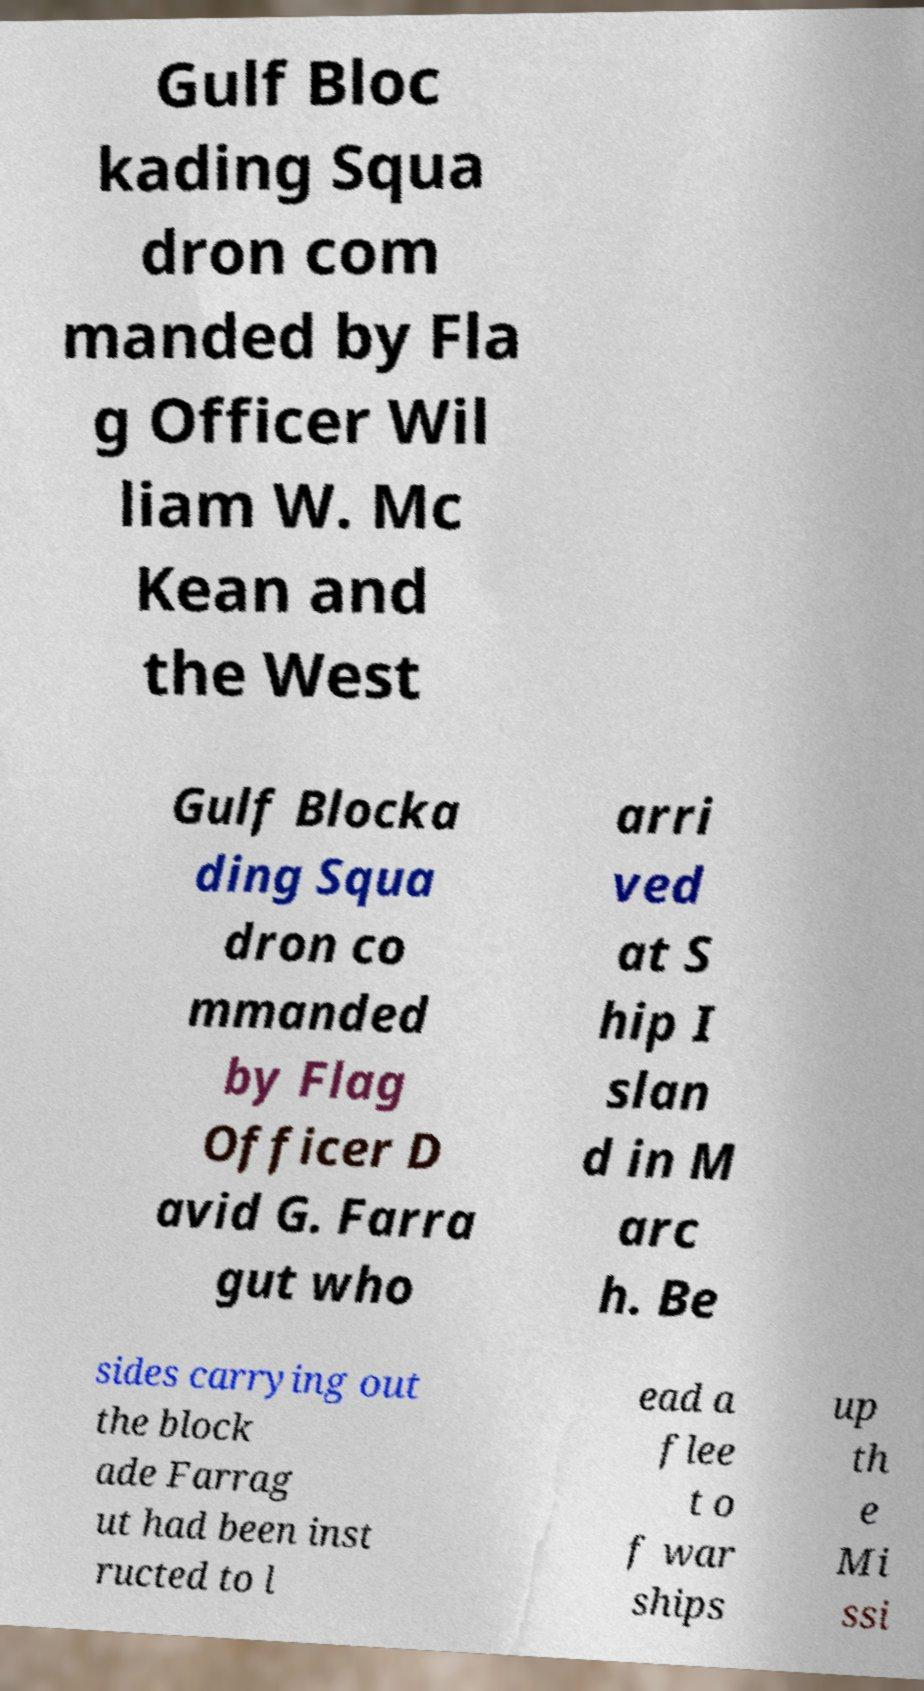Could you assist in decoding the text presented in this image and type it out clearly? Gulf Bloc kading Squa dron com manded by Fla g Officer Wil liam W. Mc Kean and the West Gulf Blocka ding Squa dron co mmanded by Flag Officer D avid G. Farra gut who arri ved at S hip I slan d in M arc h. Be sides carrying out the block ade Farrag ut had been inst ructed to l ead a flee t o f war ships up th e Mi ssi 